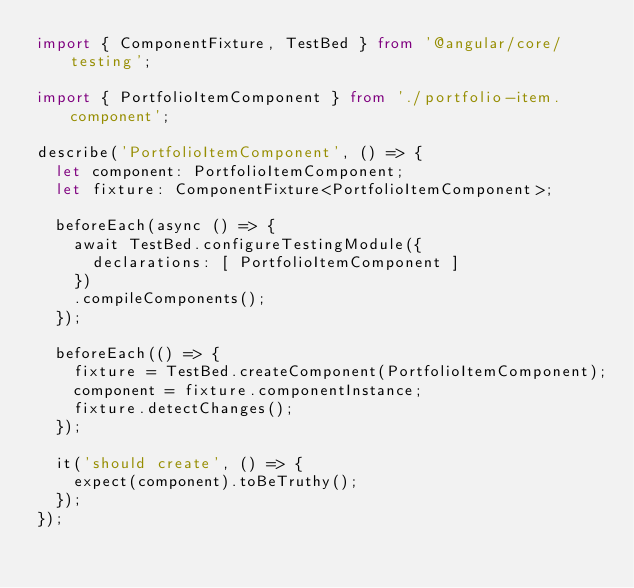Convert code to text. <code><loc_0><loc_0><loc_500><loc_500><_TypeScript_>import { ComponentFixture, TestBed } from '@angular/core/testing';

import { PortfolioItemComponent } from './portfolio-item.component';

describe('PortfolioItemComponent', () => {
  let component: PortfolioItemComponent;
  let fixture: ComponentFixture<PortfolioItemComponent>;

  beforeEach(async () => {
    await TestBed.configureTestingModule({
      declarations: [ PortfolioItemComponent ]
    })
    .compileComponents();
  });

  beforeEach(() => {
    fixture = TestBed.createComponent(PortfolioItemComponent);
    component = fixture.componentInstance;
    fixture.detectChanges();
  });

  it('should create', () => {
    expect(component).toBeTruthy();
  });
});
</code> 